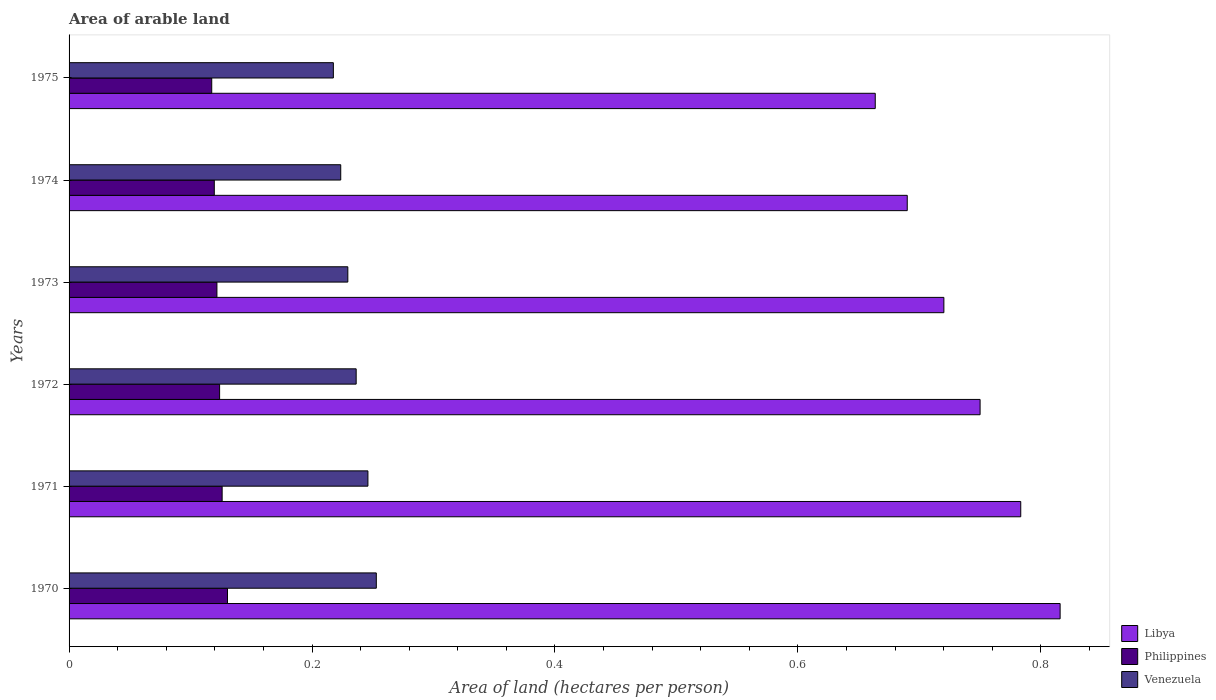How many groups of bars are there?
Offer a very short reply. 6. Are the number of bars per tick equal to the number of legend labels?
Ensure brevity in your answer.  Yes. How many bars are there on the 4th tick from the top?
Keep it short and to the point. 3. What is the label of the 3rd group of bars from the top?
Ensure brevity in your answer.  1973. What is the total arable land in Libya in 1973?
Provide a short and direct response. 0.72. Across all years, what is the maximum total arable land in Libya?
Provide a short and direct response. 0.82. Across all years, what is the minimum total arable land in Libya?
Provide a short and direct response. 0.66. In which year was the total arable land in Philippines minimum?
Your answer should be very brief. 1975. What is the total total arable land in Philippines in the graph?
Provide a succinct answer. 0.74. What is the difference between the total arable land in Libya in 1970 and that in 1974?
Make the answer very short. 0.13. What is the difference between the total arable land in Philippines in 1970 and the total arable land in Venezuela in 1971?
Your answer should be compact. -0.12. What is the average total arable land in Libya per year?
Offer a terse response. 0.74. In the year 1974, what is the difference between the total arable land in Philippines and total arable land in Venezuela?
Keep it short and to the point. -0.1. In how many years, is the total arable land in Philippines greater than 0.44 hectares per person?
Ensure brevity in your answer.  0. What is the ratio of the total arable land in Philippines in 1971 to that in 1974?
Provide a short and direct response. 1.05. Is the total arable land in Venezuela in 1970 less than that in 1974?
Make the answer very short. No. Is the difference between the total arable land in Philippines in 1971 and 1974 greater than the difference between the total arable land in Venezuela in 1971 and 1974?
Your response must be concise. No. What is the difference between the highest and the second highest total arable land in Libya?
Keep it short and to the point. 0.03. What is the difference between the highest and the lowest total arable land in Venezuela?
Your answer should be compact. 0.04. Is the sum of the total arable land in Philippines in 1971 and 1973 greater than the maximum total arable land in Libya across all years?
Give a very brief answer. No. What does the 1st bar from the top in 1971 represents?
Give a very brief answer. Venezuela. What does the 1st bar from the bottom in 1972 represents?
Your answer should be very brief. Libya. How many bars are there?
Offer a very short reply. 18. How many years are there in the graph?
Keep it short and to the point. 6. What is the difference between two consecutive major ticks on the X-axis?
Give a very brief answer. 0.2. Does the graph contain grids?
Offer a very short reply. No. Where does the legend appear in the graph?
Offer a terse response. Bottom right. How many legend labels are there?
Provide a succinct answer. 3. How are the legend labels stacked?
Make the answer very short. Vertical. What is the title of the graph?
Ensure brevity in your answer.  Area of arable land. Does "Europe(developing only)" appear as one of the legend labels in the graph?
Provide a succinct answer. No. What is the label or title of the X-axis?
Provide a short and direct response. Area of land (hectares per person). What is the Area of land (hectares per person) in Libya in 1970?
Ensure brevity in your answer.  0.82. What is the Area of land (hectares per person) in Philippines in 1970?
Give a very brief answer. 0.13. What is the Area of land (hectares per person) in Venezuela in 1970?
Your response must be concise. 0.25. What is the Area of land (hectares per person) of Libya in 1971?
Provide a short and direct response. 0.78. What is the Area of land (hectares per person) in Philippines in 1971?
Offer a terse response. 0.13. What is the Area of land (hectares per person) of Venezuela in 1971?
Give a very brief answer. 0.25. What is the Area of land (hectares per person) of Libya in 1972?
Your answer should be compact. 0.75. What is the Area of land (hectares per person) of Philippines in 1972?
Keep it short and to the point. 0.12. What is the Area of land (hectares per person) of Venezuela in 1972?
Your answer should be compact. 0.24. What is the Area of land (hectares per person) of Libya in 1973?
Keep it short and to the point. 0.72. What is the Area of land (hectares per person) of Philippines in 1973?
Your answer should be compact. 0.12. What is the Area of land (hectares per person) of Venezuela in 1973?
Keep it short and to the point. 0.23. What is the Area of land (hectares per person) of Libya in 1974?
Your answer should be compact. 0.69. What is the Area of land (hectares per person) of Philippines in 1974?
Your answer should be compact. 0.12. What is the Area of land (hectares per person) in Venezuela in 1974?
Make the answer very short. 0.22. What is the Area of land (hectares per person) of Libya in 1975?
Your response must be concise. 0.66. What is the Area of land (hectares per person) of Philippines in 1975?
Offer a very short reply. 0.12. What is the Area of land (hectares per person) of Venezuela in 1975?
Provide a short and direct response. 0.22. Across all years, what is the maximum Area of land (hectares per person) of Libya?
Your response must be concise. 0.82. Across all years, what is the maximum Area of land (hectares per person) of Philippines?
Ensure brevity in your answer.  0.13. Across all years, what is the maximum Area of land (hectares per person) in Venezuela?
Give a very brief answer. 0.25. Across all years, what is the minimum Area of land (hectares per person) in Libya?
Offer a very short reply. 0.66. Across all years, what is the minimum Area of land (hectares per person) of Philippines?
Your answer should be very brief. 0.12. Across all years, what is the minimum Area of land (hectares per person) in Venezuela?
Your answer should be compact. 0.22. What is the total Area of land (hectares per person) in Libya in the graph?
Provide a succinct answer. 4.42. What is the total Area of land (hectares per person) of Philippines in the graph?
Keep it short and to the point. 0.74. What is the total Area of land (hectares per person) of Venezuela in the graph?
Give a very brief answer. 1.41. What is the difference between the Area of land (hectares per person) of Libya in 1970 and that in 1971?
Your answer should be very brief. 0.03. What is the difference between the Area of land (hectares per person) in Philippines in 1970 and that in 1971?
Keep it short and to the point. 0. What is the difference between the Area of land (hectares per person) in Venezuela in 1970 and that in 1971?
Your response must be concise. 0.01. What is the difference between the Area of land (hectares per person) in Libya in 1970 and that in 1972?
Provide a short and direct response. 0.07. What is the difference between the Area of land (hectares per person) of Philippines in 1970 and that in 1972?
Make the answer very short. 0.01. What is the difference between the Area of land (hectares per person) in Venezuela in 1970 and that in 1972?
Your response must be concise. 0.02. What is the difference between the Area of land (hectares per person) of Libya in 1970 and that in 1973?
Your answer should be very brief. 0.1. What is the difference between the Area of land (hectares per person) of Philippines in 1970 and that in 1973?
Keep it short and to the point. 0.01. What is the difference between the Area of land (hectares per person) in Venezuela in 1970 and that in 1973?
Provide a succinct answer. 0.02. What is the difference between the Area of land (hectares per person) in Libya in 1970 and that in 1974?
Provide a succinct answer. 0.13. What is the difference between the Area of land (hectares per person) of Philippines in 1970 and that in 1974?
Keep it short and to the point. 0.01. What is the difference between the Area of land (hectares per person) of Venezuela in 1970 and that in 1974?
Provide a succinct answer. 0.03. What is the difference between the Area of land (hectares per person) of Libya in 1970 and that in 1975?
Your response must be concise. 0.15. What is the difference between the Area of land (hectares per person) of Philippines in 1970 and that in 1975?
Provide a short and direct response. 0.01. What is the difference between the Area of land (hectares per person) in Venezuela in 1970 and that in 1975?
Give a very brief answer. 0.04. What is the difference between the Area of land (hectares per person) in Libya in 1971 and that in 1972?
Keep it short and to the point. 0.03. What is the difference between the Area of land (hectares per person) of Philippines in 1971 and that in 1972?
Provide a succinct answer. 0. What is the difference between the Area of land (hectares per person) of Venezuela in 1971 and that in 1972?
Provide a short and direct response. 0.01. What is the difference between the Area of land (hectares per person) of Libya in 1971 and that in 1973?
Your answer should be compact. 0.06. What is the difference between the Area of land (hectares per person) of Philippines in 1971 and that in 1973?
Give a very brief answer. 0. What is the difference between the Area of land (hectares per person) of Venezuela in 1971 and that in 1973?
Provide a succinct answer. 0.02. What is the difference between the Area of land (hectares per person) of Libya in 1971 and that in 1974?
Give a very brief answer. 0.09. What is the difference between the Area of land (hectares per person) of Philippines in 1971 and that in 1974?
Give a very brief answer. 0.01. What is the difference between the Area of land (hectares per person) in Venezuela in 1971 and that in 1974?
Your answer should be compact. 0.02. What is the difference between the Area of land (hectares per person) in Libya in 1971 and that in 1975?
Provide a succinct answer. 0.12. What is the difference between the Area of land (hectares per person) in Philippines in 1971 and that in 1975?
Make the answer very short. 0.01. What is the difference between the Area of land (hectares per person) of Venezuela in 1971 and that in 1975?
Your response must be concise. 0.03. What is the difference between the Area of land (hectares per person) in Libya in 1972 and that in 1973?
Your response must be concise. 0.03. What is the difference between the Area of land (hectares per person) in Philippines in 1972 and that in 1973?
Keep it short and to the point. 0. What is the difference between the Area of land (hectares per person) in Venezuela in 1972 and that in 1973?
Give a very brief answer. 0.01. What is the difference between the Area of land (hectares per person) of Libya in 1972 and that in 1974?
Keep it short and to the point. 0.06. What is the difference between the Area of land (hectares per person) of Philippines in 1972 and that in 1974?
Provide a succinct answer. 0. What is the difference between the Area of land (hectares per person) in Venezuela in 1972 and that in 1974?
Your answer should be very brief. 0.01. What is the difference between the Area of land (hectares per person) in Libya in 1972 and that in 1975?
Give a very brief answer. 0.09. What is the difference between the Area of land (hectares per person) in Philippines in 1972 and that in 1975?
Your answer should be compact. 0.01. What is the difference between the Area of land (hectares per person) of Venezuela in 1972 and that in 1975?
Your answer should be compact. 0.02. What is the difference between the Area of land (hectares per person) in Libya in 1973 and that in 1974?
Keep it short and to the point. 0.03. What is the difference between the Area of land (hectares per person) of Philippines in 1973 and that in 1974?
Offer a terse response. 0. What is the difference between the Area of land (hectares per person) in Venezuela in 1973 and that in 1974?
Your answer should be compact. 0.01. What is the difference between the Area of land (hectares per person) in Libya in 1973 and that in 1975?
Keep it short and to the point. 0.06. What is the difference between the Area of land (hectares per person) of Philippines in 1973 and that in 1975?
Your answer should be very brief. 0. What is the difference between the Area of land (hectares per person) in Venezuela in 1973 and that in 1975?
Your response must be concise. 0.01. What is the difference between the Area of land (hectares per person) of Libya in 1974 and that in 1975?
Offer a terse response. 0.03. What is the difference between the Area of land (hectares per person) of Philippines in 1974 and that in 1975?
Offer a terse response. 0. What is the difference between the Area of land (hectares per person) of Venezuela in 1974 and that in 1975?
Your answer should be very brief. 0.01. What is the difference between the Area of land (hectares per person) of Libya in 1970 and the Area of land (hectares per person) of Philippines in 1971?
Give a very brief answer. 0.69. What is the difference between the Area of land (hectares per person) of Libya in 1970 and the Area of land (hectares per person) of Venezuela in 1971?
Your answer should be very brief. 0.57. What is the difference between the Area of land (hectares per person) in Philippines in 1970 and the Area of land (hectares per person) in Venezuela in 1971?
Your answer should be very brief. -0.12. What is the difference between the Area of land (hectares per person) in Libya in 1970 and the Area of land (hectares per person) in Philippines in 1972?
Provide a succinct answer. 0.69. What is the difference between the Area of land (hectares per person) of Libya in 1970 and the Area of land (hectares per person) of Venezuela in 1972?
Provide a succinct answer. 0.58. What is the difference between the Area of land (hectares per person) in Philippines in 1970 and the Area of land (hectares per person) in Venezuela in 1972?
Your response must be concise. -0.11. What is the difference between the Area of land (hectares per person) in Libya in 1970 and the Area of land (hectares per person) in Philippines in 1973?
Provide a short and direct response. 0.69. What is the difference between the Area of land (hectares per person) of Libya in 1970 and the Area of land (hectares per person) of Venezuela in 1973?
Give a very brief answer. 0.59. What is the difference between the Area of land (hectares per person) of Philippines in 1970 and the Area of land (hectares per person) of Venezuela in 1973?
Offer a terse response. -0.1. What is the difference between the Area of land (hectares per person) of Libya in 1970 and the Area of land (hectares per person) of Philippines in 1974?
Keep it short and to the point. 0.7. What is the difference between the Area of land (hectares per person) in Libya in 1970 and the Area of land (hectares per person) in Venezuela in 1974?
Make the answer very short. 0.59. What is the difference between the Area of land (hectares per person) in Philippines in 1970 and the Area of land (hectares per person) in Venezuela in 1974?
Offer a very short reply. -0.09. What is the difference between the Area of land (hectares per person) of Libya in 1970 and the Area of land (hectares per person) of Philippines in 1975?
Provide a short and direct response. 0.7. What is the difference between the Area of land (hectares per person) of Libya in 1970 and the Area of land (hectares per person) of Venezuela in 1975?
Offer a very short reply. 0.6. What is the difference between the Area of land (hectares per person) in Philippines in 1970 and the Area of land (hectares per person) in Venezuela in 1975?
Make the answer very short. -0.09. What is the difference between the Area of land (hectares per person) of Libya in 1971 and the Area of land (hectares per person) of Philippines in 1972?
Your answer should be very brief. 0.66. What is the difference between the Area of land (hectares per person) in Libya in 1971 and the Area of land (hectares per person) in Venezuela in 1972?
Keep it short and to the point. 0.55. What is the difference between the Area of land (hectares per person) of Philippines in 1971 and the Area of land (hectares per person) of Venezuela in 1972?
Offer a very short reply. -0.11. What is the difference between the Area of land (hectares per person) of Libya in 1971 and the Area of land (hectares per person) of Philippines in 1973?
Your response must be concise. 0.66. What is the difference between the Area of land (hectares per person) of Libya in 1971 and the Area of land (hectares per person) of Venezuela in 1973?
Offer a very short reply. 0.55. What is the difference between the Area of land (hectares per person) of Philippines in 1971 and the Area of land (hectares per person) of Venezuela in 1973?
Ensure brevity in your answer.  -0.1. What is the difference between the Area of land (hectares per person) in Libya in 1971 and the Area of land (hectares per person) in Philippines in 1974?
Offer a terse response. 0.66. What is the difference between the Area of land (hectares per person) of Libya in 1971 and the Area of land (hectares per person) of Venezuela in 1974?
Offer a terse response. 0.56. What is the difference between the Area of land (hectares per person) in Philippines in 1971 and the Area of land (hectares per person) in Venezuela in 1974?
Make the answer very short. -0.1. What is the difference between the Area of land (hectares per person) in Libya in 1971 and the Area of land (hectares per person) in Philippines in 1975?
Ensure brevity in your answer.  0.67. What is the difference between the Area of land (hectares per person) of Libya in 1971 and the Area of land (hectares per person) of Venezuela in 1975?
Offer a very short reply. 0.57. What is the difference between the Area of land (hectares per person) of Philippines in 1971 and the Area of land (hectares per person) of Venezuela in 1975?
Offer a very short reply. -0.09. What is the difference between the Area of land (hectares per person) of Libya in 1972 and the Area of land (hectares per person) of Philippines in 1973?
Your answer should be very brief. 0.63. What is the difference between the Area of land (hectares per person) in Libya in 1972 and the Area of land (hectares per person) in Venezuela in 1973?
Your answer should be very brief. 0.52. What is the difference between the Area of land (hectares per person) in Philippines in 1972 and the Area of land (hectares per person) in Venezuela in 1973?
Provide a succinct answer. -0.11. What is the difference between the Area of land (hectares per person) in Libya in 1972 and the Area of land (hectares per person) in Philippines in 1974?
Your answer should be very brief. 0.63. What is the difference between the Area of land (hectares per person) in Libya in 1972 and the Area of land (hectares per person) in Venezuela in 1974?
Your answer should be compact. 0.53. What is the difference between the Area of land (hectares per person) in Philippines in 1972 and the Area of land (hectares per person) in Venezuela in 1974?
Your response must be concise. -0.1. What is the difference between the Area of land (hectares per person) of Libya in 1972 and the Area of land (hectares per person) of Philippines in 1975?
Provide a succinct answer. 0.63. What is the difference between the Area of land (hectares per person) of Libya in 1972 and the Area of land (hectares per person) of Venezuela in 1975?
Provide a succinct answer. 0.53. What is the difference between the Area of land (hectares per person) of Philippines in 1972 and the Area of land (hectares per person) of Venezuela in 1975?
Offer a very short reply. -0.09. What is the difference between the Area of land (hectares per person) in Libya in 1973 and the Area of land (hectares per person) in Philippines in 1974?
Your answer should be compact. 0.6. What is the difference between the Area of land (hectares per person) of Libya in 1973 and the Area of land (hectares per person) of Venezuela in 1974?
Offer a terse response. 0.5. What is the difference between the Area of land (hectares per person) of Philippines in 1973 and the Area of land (hectares per person) of Venezuela in 1974?
Make the answer very short. -0.1. What is the difference between the Area of land (hectares per person) in Libya in 1973 and the Area of land (hectares per person) in Philippines in 1975?
Your response must be concise. 0.6. What is the difference between the Area of land (hectares per person) in Libya in 1973 and the Area of land (hectares per person) in Venezuela in 1975?
Offer a terse response. 0.5. What is the difference between the Area of land (hectares per person) in Philippines in 1973 and the Area of land (hectares per person) in Venezuela in 1975?
Give a very brief answer. -0.1. What is the difference between the Area of land (hectares per person) of Libya in 1974 and the Area of land (hectares per person) of Philippines in 1975?
Make the answer very short. 0.57. What is the difference between the Area of land (hectares per person) of Libya in 1974 and the Area of land (hectares per person) of Venezuela in 1975?
Your answer should be very brief. 0.47. What is the difference between the Area of land (hectares per person) of Philippines in 1974 and the Area of land (hectares per person) of Venezuela in 1975?
Make the answer very short. -0.1. What is the average Area of land (hectares per person) in Libya per year?
Make the answer very short. 0.74. What is the average Area of land (hectares per person) in Philippines per year?
Your answer should be very brief. 0.12. What is the average Area of land (hectares per person) of Venezuela per year?
Your answer should be very brief. 0.23. In the year 1970, what is the difference between the Area of land (hectares per person) in Libya and Area of land (hectares per person) in Philippines?
Offer a terse response. 0.69. In the year 1970, what is the difference between the Area of land (hectares per person) of Libya and Area of land (hectares per person) of Venezuela?
Ensure brevity in your answer.  0.56. In the year 1970, what is the difference between the Area of land (hectares per person) of Philippines and Area of land (hectares per person) of Venezuela?
Ensure brevity in your answer.  -0.12. In the year 1971, what is the difference between the Area of land (hectares per person) in Libya and Area of land (hectares per person) in Philippines?
Give a very brief answer. 0.66. In the year 1971, what is the difference between the Area of land (hectares per person) of Libya and Area of land (hectares per person) of Venezuela?
Your response must be concise. 0.54. In the year 1971, what is the difference between the Area of land (hectares per person) of Philippines and Area of land (hectares per person) of Venezuela?
Your answer should be compact. -0.12. In the year 1972, what is the difference between the Area of land (hectares per person) in Libya and Area of land (hectares per person) in Philippines?
Your answer should be very brief. 0.63. In the year 1972, what is the difference between the Area of land (hectares per person) of Libya and Area of land (hectares per person) of Venezuela?
Offer a terse response. 0.51. In the year 1972, what is the difference between the Area of land (hectares per person) in Philippines and Area of land (hectares per person) in Venezuela?
Provide a short and direct response. -0.11. In the year 1973, what is the difference between the Area of land (hectares per person) of Libya and Area of land (hectares per person) of Philippines?
Give a very brief answer. 0.6. In the year 1973, what is the difference between the Area of land (hectares per person) of Libya and Area of land (hectares per person) of Venezuela?
Provide a succinct answer. 0.49. In the year 1973, what is the difference between the Area of land (hectares per person) of Philippines and Area of land (hectares per person) of Venezuela?
Give a very brief answer. -0.11. In the year 1974, what is the difference between the Area of land (hectares per person) in Libya and Area of land (hectares per person) in Philippines?
Keep it short and to the point. 0.57. In the year 1974, what is the difference between the Area of land (hectares per person) in Libya and Area of land (hectares per person) in Venezuela?
Offer a terse response. 0.47. In the year 1974, what is the difference between the Area of land (hectares per person) in Philippines and Area of land (hectares per person) in Venezuela?
Offer a terse response. -0.1. In the year 1975, what is the difference between the Area of land (hectares per person) in Libya and Area of land (hectares per person) in Philippines?
Your answer should be compact. 0.55. In the year 1975, what is the difference between the Area of land (hectares per person) of Libya and Area of land (hectares per person) of Venezuela?
Give a very brief answer. 0.45. In the year 1975, what is the difference between the Area of land (hectares per person) of Philippines and Area of land (hectares per person) of Venezuela?
Your answer should be very brief. -0.1. What is the ratio of the Area of land (hectares per person) in Libya in 1970 to that in 1971?
Provide a succinct answer. 1.04. What is the ratio of the Area of land (hectares per person) in Philippines in 1970 to that in 1971?
Make the answer very short. 1.03. What is the ratio of the Area of land (hectares per person) of Venezuela in 1970 to that in 1971?
Ensure brevity in your answer.  1.03. What is the ratio of the Area of land (hectares per person) in Libya in 1970 to that in 1972?
Make the answer very short. 1.09. What is the ratio of the Area of land (hectares per person) in Philippines in 1970 to that in 1972?
Keep it short and to the point. 1.05. What is the ratio of the Area of land (hectares per person) in Venezuela in 1970 to that in 1972?
Ensure brevity in your answer.  1.07. What is the ratio of the Area of land (hectares per person) in Libya in 1970 to that in 1973?
Offer a very short reply. 1.13. What is the ratio of the Area of land (hectares per person) in Philippines in 1970 to that in 1973?
Your answer should be compact. 1.07. What is the ratio of the Area of land (hectares per person) in Venezuela in 1970 to that in 1973?
Your answer should be very brief. 1.1. What is the ratio of the Area of land (hectares per person) in Libya in 1970 to that in 1974?
Your answer should be very brief. 1.18. What is the ratio of the Area of land (hectares per person) of Philippines in 1970 to that in 1974?
Provide a short and direct response. 1.09. What is the ratio of the Area of land (hectares per person) of Venezuela in 1970 to that in 1974?
Your answer should be very brief. 1.13. What is the ratio of the Area of land (hectares per person) of Libya in 1970 to that in 1975?
Offer a terse response. 1.23. What is the ratio of the Area of land (hectares per person) of Philippines in 1970 to that in 1975?
Ensure brevity in your answer.  1.11. What is the ratio of the Area of land (hectares per person) of Venezuela in 1970 to that in 1975?
Provide a succinct answer. 1.16. What is the ratio of the Area of land (hectares per person) of Libya in 1971 to that in 1972?
Your answer should be very brief. 1.04. What is the ratio of the Area of land (hectares per person) in Philippines in 1971 to that in 1972?
Your answer should be compact. 1.02. What is the ratio of the Area of land (hectares per person) in Venezuela in 1971 to that in 1972?
Offer a very short reply. 1.04. What is the ratio of the Area of land (hectares per person) of Libya in 1971 to that in 1973?
Keep it short and to the point. 1.09. What is the ratio of the Area of land (hectares per person) in Philippines in 1971 to that in 1973?
Ensure brevity in your answer.  1.04. What is the ratio of the Area of land (hectares per person) of Venezuela in 1971 to that in 1973?
Ensure brevity in your answer.  1.07. What is the ratio of the Area of land (hectares per person) in Libya in 1971 to that in 1974?
Provide a succinct answer. 1.14. What is the ratio of the Area of land (hectares per person) of Philippines in 1971 to that in 1974?
Your answer should be compact. 1.05. What is the ratio of the Area of land (hectares per person) in Venezuela in 1971 to that in 1974?
Offer a very short reply. 1.1. What is the ratio of the Area of land (hectares per person) of Libya in 1971 to that in 1975?
Ensure brevity in your answer.  1.18. What is the ratio of the Area of land (hectares per person) in Philippines in 1971 to that in 1975?
Provide a short and direct response. 1.07. What is the ratio of the Area of land (hectares per person) in Venezuela in 1971 to that in 1975?
Your answer should be compact. 1.13. What is the ratio of the Area of land (hectares per person) in Libya in 1972 to that in 1973?
Offer a terse response. 1.04. What is the ratio of the Area of land (hectares per person) of Philippines in 1972 to that in 1973?
Make the answer very short. 1.02. What is the ratio of the Area of land (hectares per person) of Venezuela in 1972 to that in 1973?
Offer a very short reply. 1.03. What is the ratio of the Area of land (hectares per person) in Libya in 1972 to that in 1974?
Your answer should be compact. 1.09. What is the ratio of the Area of land (hectares per person) of Philippines in 1972 to that in 1974?
Make the answer very short. 1.04. What is the ratio of the Area of land (hectares per person) of Venezuela in 1972 to that in 1974?
Provide a short and direct response. 1.06. What is the ratio of the Area of land (hectares per person) of Libya in 1972 to that in 1975?
Your answer should be compact. 1.13. What is the ratio of the Area of land (hectares per person) of Philippines in 1972 to that in 1975?
Provide a succinct answer. 1.06. What is the ratio of the Area of land (hectares per person) in Venezuela in 1972 to that in 1975?
Your answer should be compact. 1.09. What is the ratio of the Area of land (hectares per person) of Libya in 1973 to that in 1974?
Your answer should be compact. 1.04. What is the ratio of the Area of land (hectares per person) of Philippines in 1973 to that in 1974?
Your answer should be very brief. 1.02. What is the ratio of the Area of land (hectares per person) in Venezuela in 1973 to that in 1974?
Provide a short and direct response. 1.03. What is the ratio of the Area of land (hectares per person) of Libya in 1973 to that in 1975?
Provide a short and direct response. 1.09. What is the ratio of the Area of land (hectares per person) in Philippines in 1973 to that in 1975?
Provide a succinct answer. 1.04. What is the ratio of the Area of land (hectares per person) in Venezuela in 1973 to that in 1975?
Ensure brevity in your answer.  1.05. What is the ratio of the Area of land (hectares per person) in Libya in 1974 to that in 1975?
Your answer should be very brief. 1.04. What is the ratio of the Area of land (hectares per person) in Philippines in 1974 to that in 1975?
Your answer should be very brief. 1.02. What is the ratio of the Area of land (hectares per person) of Venezuela in 1974 to that in 1975?
Give a very brief answer. 1.03. What is the difference between the highest and the second highest Area of land (hectares per person) of Libya?
Your answer should be very brief. 0.03. What is the difference between the highest and the second highest Area of land (hectares per person) of Philippines?
Keep it short and to the point. 0. What is the difference between the highest and the second highest Area of land (hectares per person) of Venezuela?
Offer a very short reply. 0.01. What is the difference between the highest and the lowest Area of land (hectares per person) in Libya?
Provide a succinct answer. 0.15. What is the difference between the highest and the lowest Area of land (hectares per person) in Philippines?
Make the answer very short. 0.01. What is the difference between the highest and the lowest Area of land (hectares per person) of Venezuela?
Give a very brief answer. 0.04. 